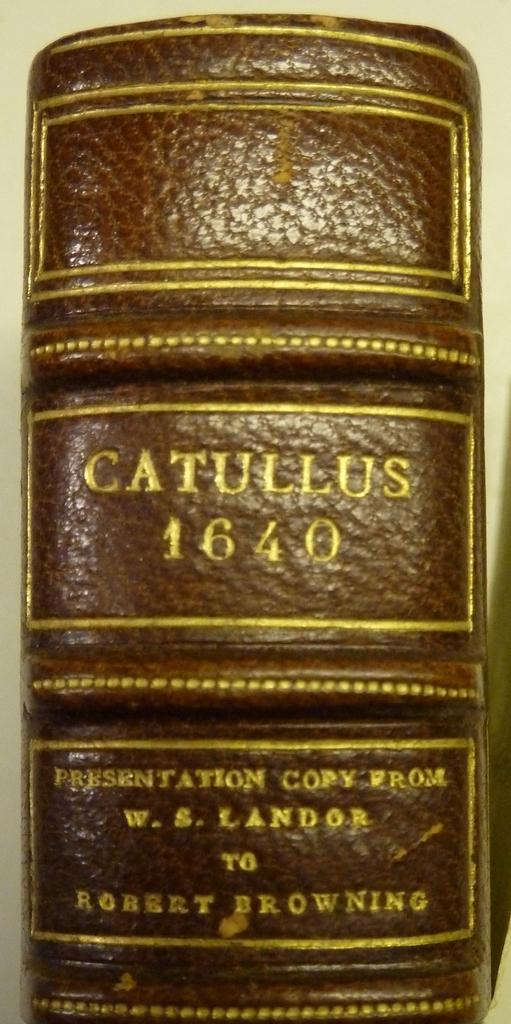<image>
Create a compact narrative representing the image presented. A leather bound copy of the Catullus 1640 vook. 